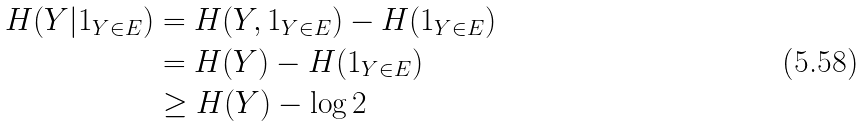Convert formula to latex. <formula><loc_0><loc_0><loc_500><loc_500>H ( Y | 1 _ { Y \in E } ) & = H ( Y , 1 _ { Y \in E } ) - H ( 1 _ { Y \in E } ) \\ & = H ( Y ) - H ( 1 _ { Y \in E } ) \\ & \geq H ( Y ) - \log 2</formula> 